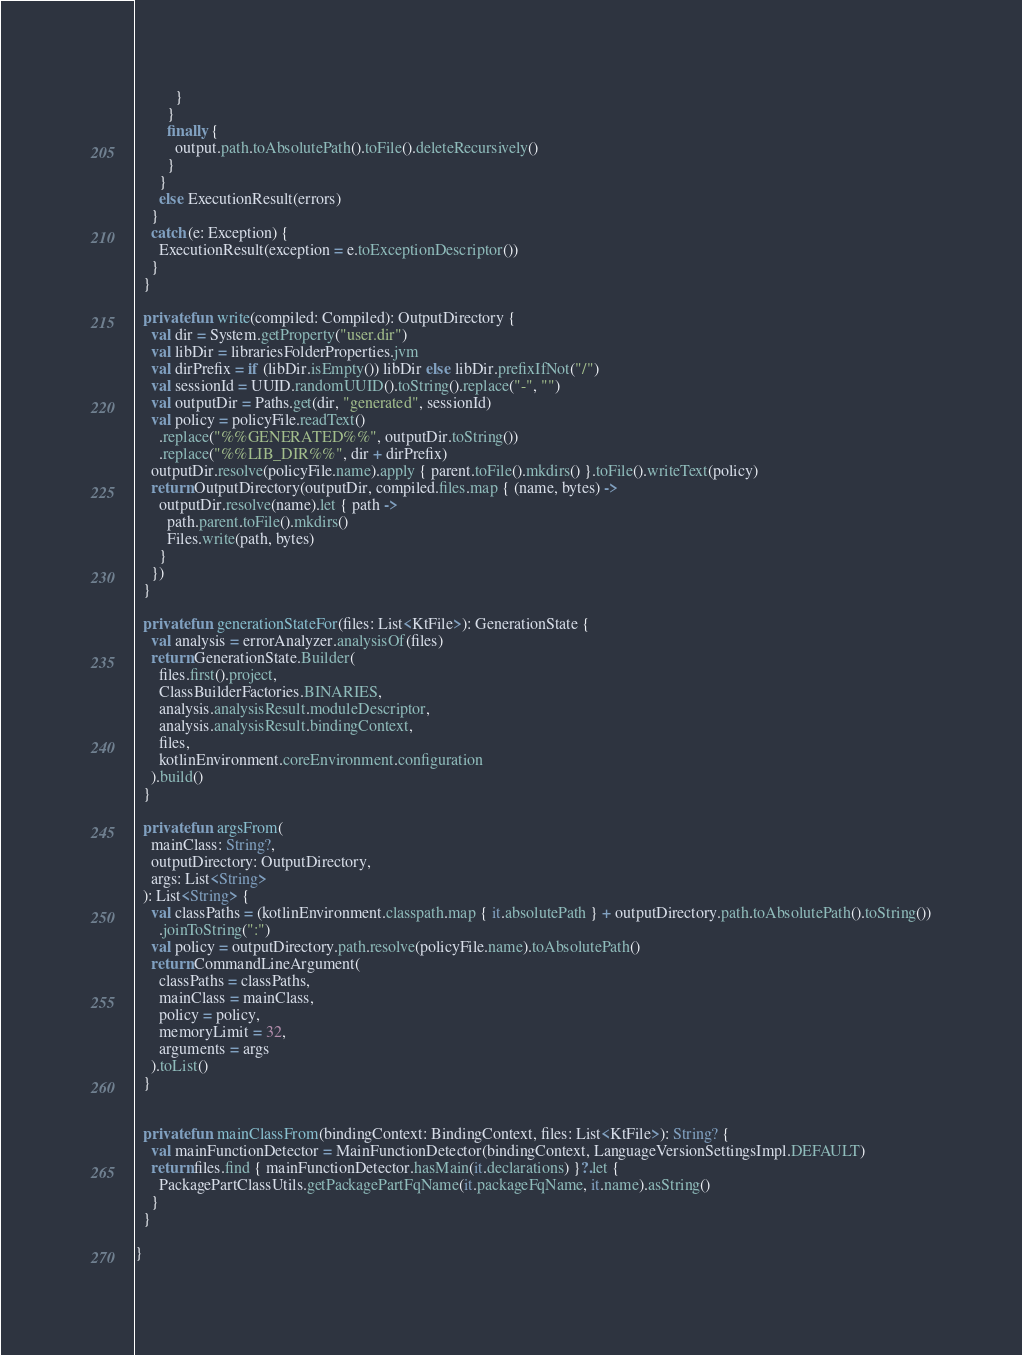Convert code to text. <code><loc_0><loc_0><loc_500><loc_500><_Kotlin_>          }
        }
        finally {
          output.path.toAbsolutePath().toFile().deleteRecursively()
        }
      }
      else ExecutionResult(errors)
    }
    catch (e: Exception) {
      ExecutionResult(exception = e.toExceptionDescriptor())
    }
  }

  private fun write(compiled: Compiled): OutputDirectory {
    val dir = System.getProperty("user.dir")
    val libDir = librariesFolderProperties.jvm
    val dirPrefix = if (libDir.isEmpty()) libDir else libDir.prefixIfNot("/")
    val sessionId = UUID.randomUUID().toString().replace("-", "")
    val outputDir = Paths.get(dir, "generated", sessionId)
    val policy = policyFile.readText()
      .replace("%%GENERATED%%", outputDir.toString())
      .replace("%%LIB_DIR%%", dir + dirPrefix)
    outputDir.resolve(policyFile.name).apply { parent.toFile().mkdirs() }.toFile().writeText(policy)
    return OutputDirectory(outputDir, compiled.files.map { (name, bytes) ->
      outputDir.resolve(name).let { path ->
        path.parent.toFile().mkdirs()
        Files.write(path, bytes)
      }
    })
  }

  private fun generationStateFor(files: List<KtFile>): GenerationState {
    val analysis = errorAnalyzer.analysisOf(files)
    return GenerationState.Builder(
      files.first().project,
      ClassBuilderFactories.BINARIES,
      analysis.analysisResult.moduleDescriptor,
      analysis.analysisResult.bindingContext,
      files,
      kotlinEnvironment.coreEnvironment.configuration
    ).build()
  }

  private fun argsFrom(
    mainClass: String?,
    outputDirectory: OutputDirectory,
    args: List<String>
  ): List<String> {
    val classPaths = (kotlinEnvironment.classpath.map { it.absolutePath } + outputDirectory.path.toAbsolutePath().toString())
      .joinToString(":")
    val policy = outputDirectory.path.resolve(policyFile.name).toAbsolutePath()
    return CommandLineArgument(
      classPaths = classPaths,
      mainClass = mainClass,
      policy = policy,
      memoryLimit = 32,
      arguments = args
    ).toList()
  }


  private fun mainClassFrom(bindingContext: BindingContext, files: List<KtFile>): String? {
    val mainFunctionDetector = MainFunctionDetector(bindingContext, LanguageVersionSettingsImpl.DEFAULT)
    return files.find { mainFunctionDetector.hasMain(it.declarations) }?.let {
      PackagePartClassUtils.getPackagePartFqName(it.packageFqName, it.name).asString()
    }
  }

}</code> 